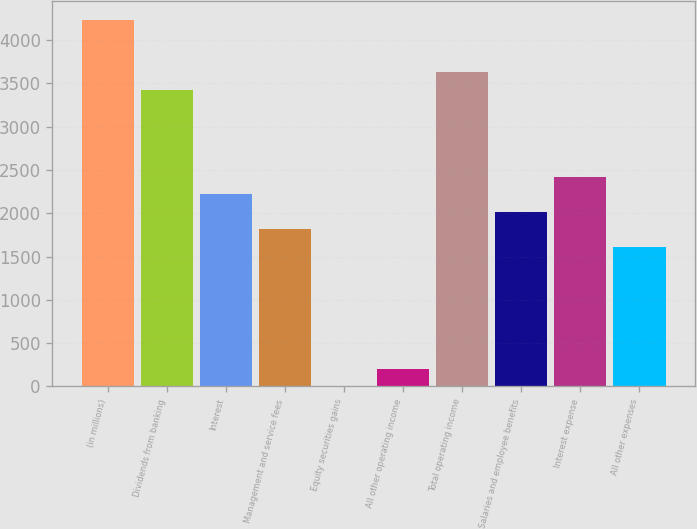<chart> <loc_0><loc_0><loc_500><loc_500><bar_chart><fcel>(in millions)<fcel>Dividends from banking<fcel>Interest<fcel>Management and service fees<fcel>Equity securities gains<fcel>All other operating income<fcel>Total operating income<fcel>Salaries and employee benefits<fcel>Interest expense<fcel>All other expenses<nl><fcel>4234.6<fcel>3428.2<fcel>2218.6<fcel>1815.4<fcel>1<fcel>202.6<fcel>3629.8<fcel>2017<fcel>2420.2<fcel>1613.8<nl></chart> 